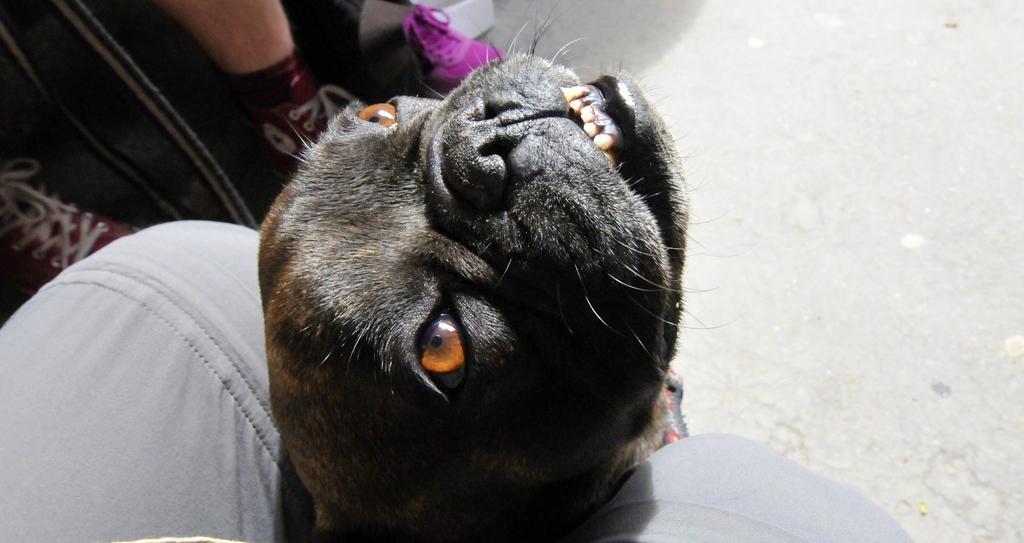Could you give a brief overview of what you see in this image? In this image there is a dog in between the legs of a person, in front of the person there are legs of another person. 